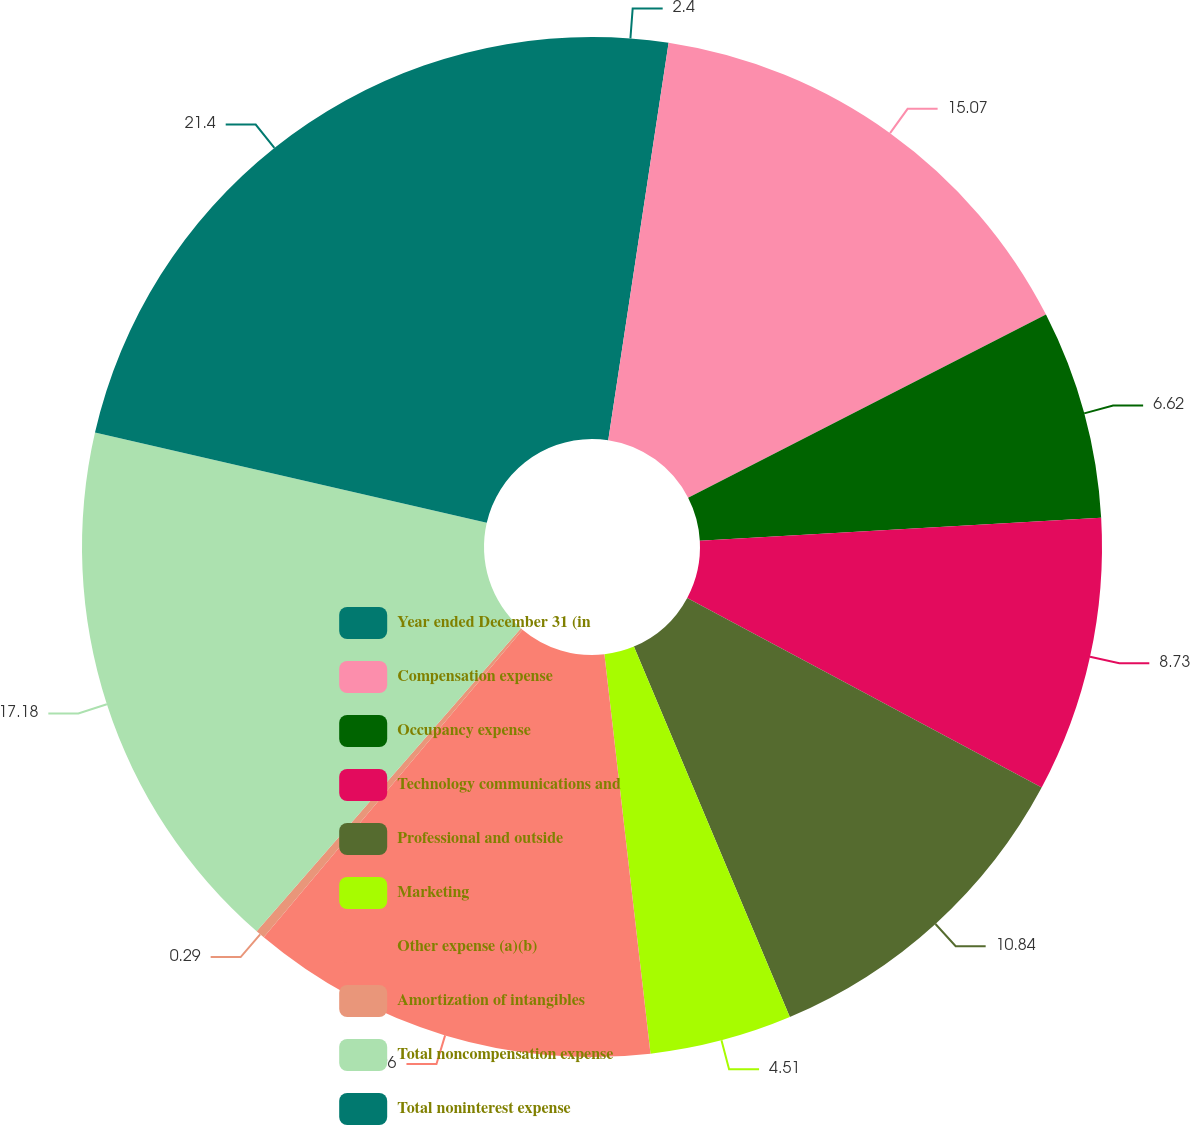<chart> <loc_0><loc_0><loc_500><loc_500><pie_chart><fcel>Year ended December 31 (in<fcel>Compensation expense<fcel>Occupancy expense<fcel>Technology communications and<fcel>Professional and outside<fcel>Marketing<fcel>Other expense (a)(b)<fcel>Amortization of intangibles<fcel>Total noncompensation expense<fcel>Total noninterest expense<nl><fcel>2.4%<fcel>15.07%<fcel>6.62%<fcel>8.73%<fcel>10.84%<fcel>4.51%<fcel>12.96%<fcel>0.29%<fcel>17.18%<fcel>21.4%<nl></chart> 